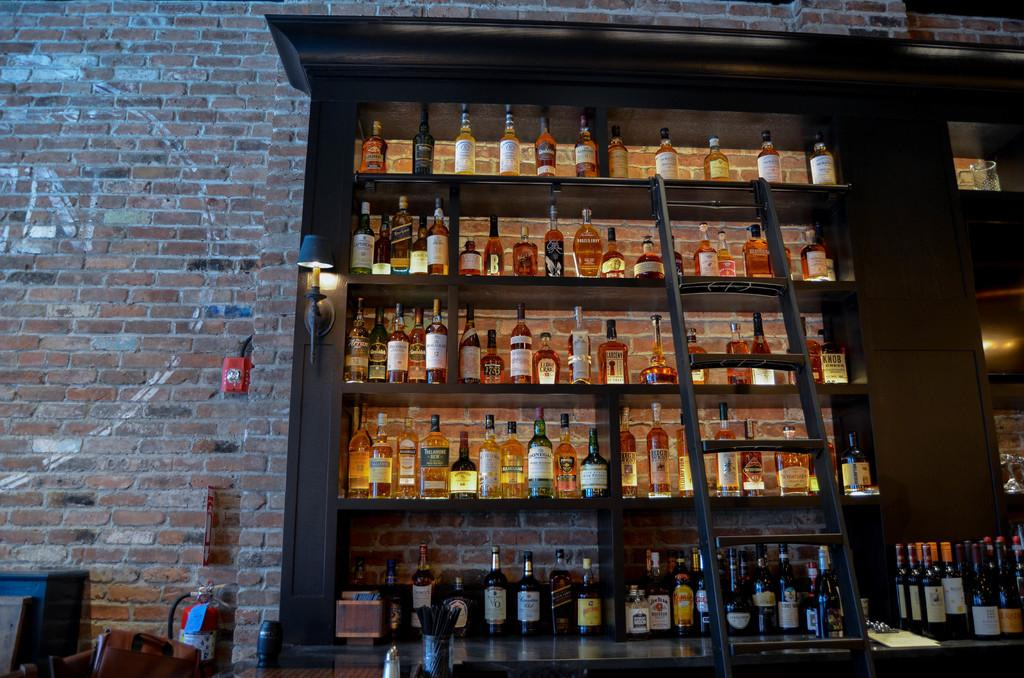What type of storage units are present in the image? There are wooden shelves in the image. What can be found on the shelves? The shelves are filled with bottles. What type of wall can be seen in the image? There is a brick wall in the image. Is there any equipment for reaching higher shelves in the image? Yes, there is a ladder in the image. Where is the team sitting on the sofa in the image? There is no team or sofa present in the image. What type of thread is being used to sew the cushions on the sofa in the image? There is no sofa or cushions present in the image, so there is no thread being used. 